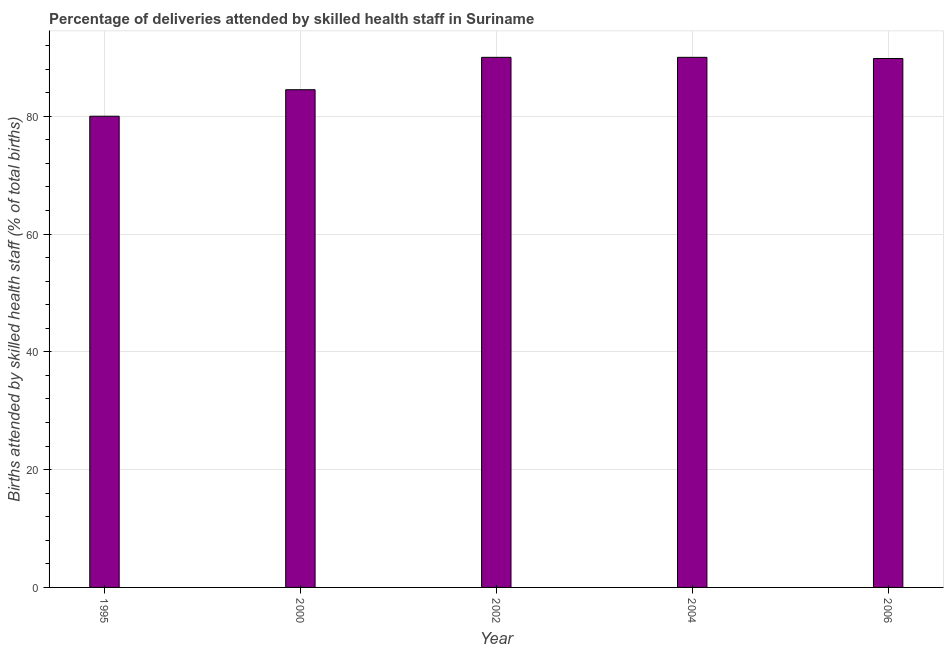Does the graph contain any zero values?
Offer a terse response. No. What is the title of the graph?
Make the answer very short. Percentage of deliveries attended by skilled health staff in Suriname. What is the label or title of the Y-axis?
Offer a very short reply. Births attended by skilled health staff (% of total births). In which year was the number of births attended by skilled health staff maximum?
Your response must be concise. 2002. What is the sum of the number of births attended by skilled health staff?
Provide a succinct answer. 434.3. What is the difference between the number of births attended by skilled health staff in 2002 and 2004?
Offer a very short reply. 0. What is the average number of births attended by skilled health staff per year?
Your response must be concise. 86.86. What is the median number of births attended by skilled health staff?
Provide a short and direct response. 89.8. In how many years, is the number of births attended by skilled health staff greater than 24 %?
Offer a terse response. 5. Is the number of births attended by skilled health staff in 2000 less than that in 2004?
Keep it short and to the point. Yes. What is the difference between the highest and the second highest number of births attended by skilled health staff?
Your response must be concise. 0. What is the difference between the highest and the lowest number of births attended by skilled health staff?
Provide a short and direct response. 10. In how many years, is the number of births attended by skilled health staff greater than the average number of births attended by skilled health staff taken over all years?
Keep it short and to the point. 3. Are all the bars in the graph horizontal?
Make the answer very short. No. Are the values on the major ticks of Y-axis written in scientific E-notation?
Provide a short and direct response. No. What is the Births attended by skilled health staff (% of total births) of 1995?
Provide a short and direct response. 80. What is the Births attended by skilled health staff (% of total births) of 2000?
Give a very brief answer. 84.5. What is the Births attended by skilled health staff (% of total births) in 2002?
Provide a short and direct response. 90. What is the Births attended by skilled health staff (% of total births) in 2006?
Your answer should be very brief. 89.8. What is the difference between the Births attended by skilled health staff (% of total births) in 1995 and 2000?
Provide a short and direct response. -4.5. What is the difference between the Births attended by skilled health staff (% of total births) in 1995 and 2006?
Keep it short and to the point. -9.8. What is the difference between the Births attended by skilled health staff (% of total births) in 2000 and 2006?
Provide a short and direct response. -5.3. What is the difference between the Births attended by skilled health staff (% of total births) in 2004 and 2006?
Give a very brief answer. 0.2. What is the ratio of the Births attended by skilled health staff (% of total births) in 1995 to that in 2000?
Give a very brief answer. 0.95. What is the ratio of the Births attended by skilled health staff (% of total births) in 1995 to that in 2002?
Offer a very short reply. 0.89. What is the ratio of the Births attended by skilled health staff (% of total births) in 1995 to that in 2004?
Provide a succinct answer. 0.89. What is the ratio of the Births attended by skilled health staff (% of total births) in 1995 to that in 2006?
Make the answer very short. 0.89. What is the ratio of the Births attended by skilled health staff (% of total births) in 2000 to that in 2002?
Provide a short and direct response. 0.94. What is the ratio of the Births attended by skilled health staff (% of total births) in 2000 to that in 2004?
Your answer should be compact. 0.94. What is the ratio of the Births attended by skilled health staff (% of total births) in 2000 to that in 2006?
Keep it short and to the point. 0.94. What is the ratio of the Births attended by skilled health staff (% of total births) in 2002 to that in 2004?
Provide a succinct answer. 1. 